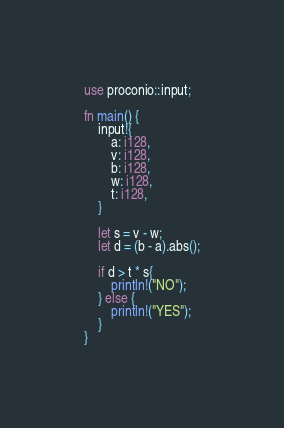Convert code to text. <code><loc_0><loc_0><loc_500><loc_500><_Rust_>use proconio::input;

fn main() {
    input!{
        a: i128,
        v: i128,
        b: i128,
        w: i128,
        t: i128,
    }
    
    let s = v - w;
    let d = (b - a).abs();

    if d > t * s{
        println!("NO");
    } else {
        println!("YES");
    }
}
</code> 